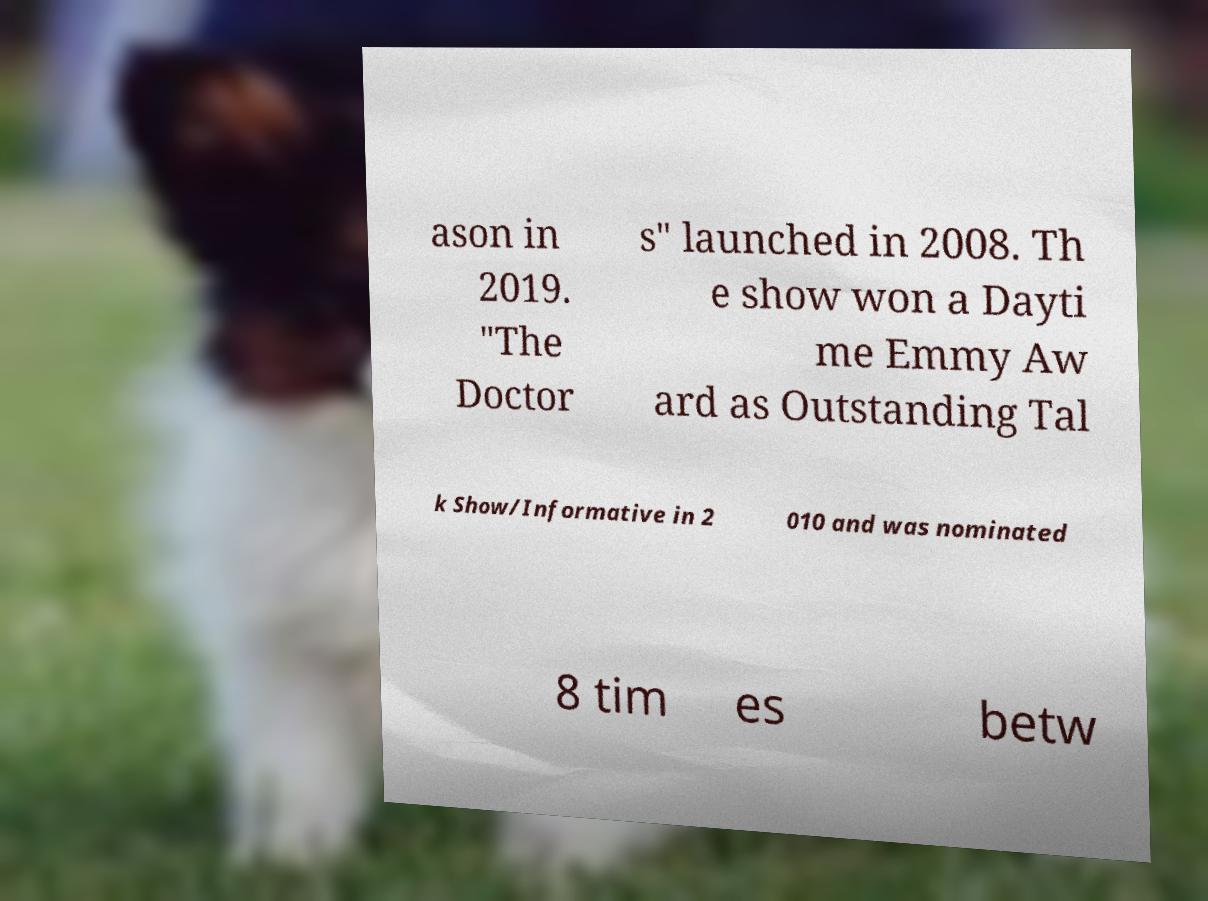Could you assist in decoding the text presented in this image and type it out clearly? ason in 2019. "The Doctor s" launched in 2008. Th e show won a Dayti me Emmy Aw ard as Outstanding Tal k Show/Informative in 2 010 and was nominated 8 tim es betw 